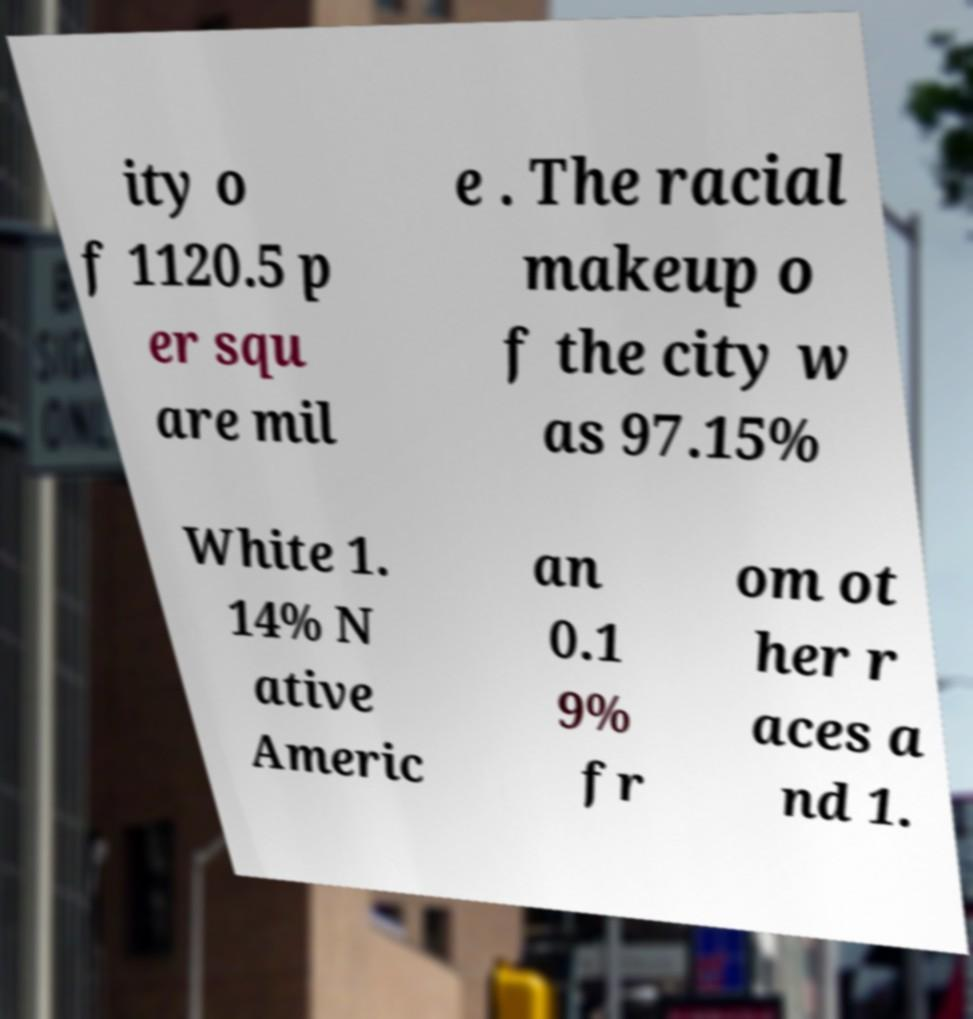There's text embedded in this image that I need extracted. Can you transcribe it verbatim? ity o f 1120.5 p er squ are mil e . The racial makeup o f the city w as 97.15% White 1. 14% N ative Americ an 0.1 9% fr om ot her r aces a nd 1. 